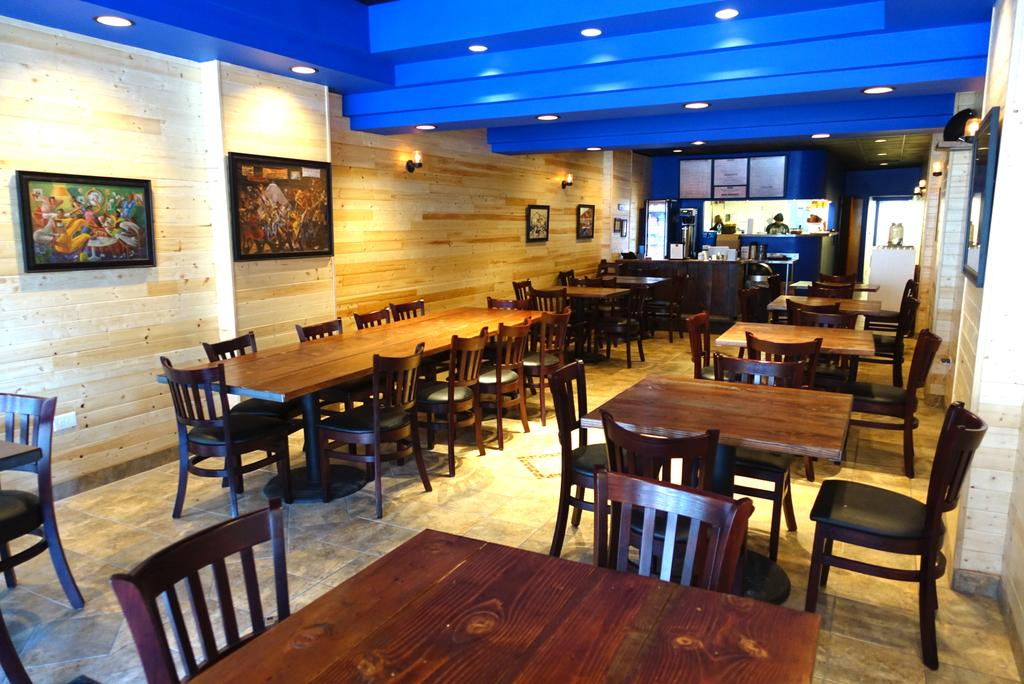What type of furniture is on the floor in the image? There are tables and chairs on the floor in the image. What can be seen in the background of the image? There is a wall, photo frames, people, lights, and some unspecified objects in the background. How many dogs are present in the image? There are no dogs present in the image. Are the people in the background brothers? The relationship between the people in the background cannot be determined from the image. 